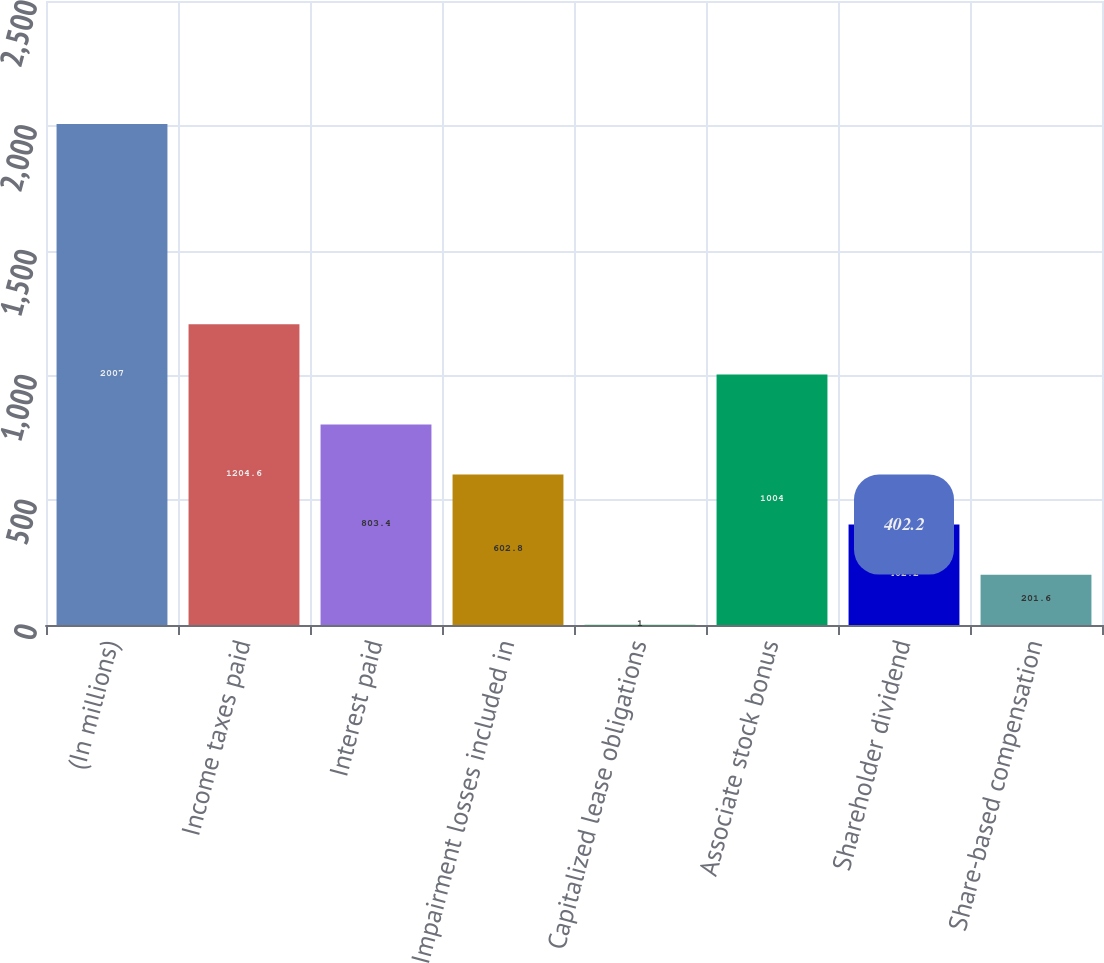<chart> <loc_0><loc_0><loc_500><loc_500><bar_chart><fcel>(In millions)<fcel>Income taxes paid<fcel>Interest paid<fcel>Impairment losses included in<fcel>Capitalized lease obligations<fcel>Associate stock bonus<fcel>Shareholder dividend<fcel>Share-based compensation<nl><fcel>2007<fcel>1204.6<fcel>803.4<fcel>602.8<fcel>1<fcel>1004<fcel>402.2<fcel>201.6<nl></chart> 